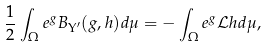Convert formula to latex. <formula><loc_0><loc_0><loc_500><loc_500>\frac { 1 } { 2 } \int _ { \Omega } e ^ { g } B _ { \Upsilon ^ { \prime } } ( g , h ) d \mu = - \int _ { \Omega } e ^ { g } \mathcal { L } h d \mu ,</formula> 